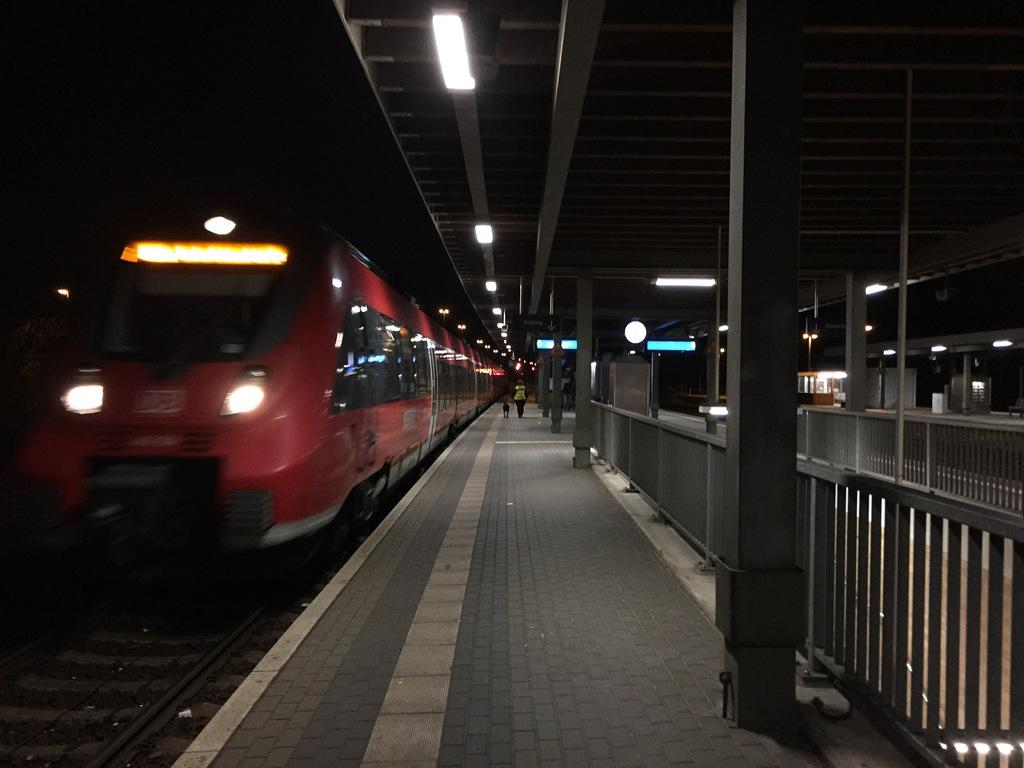What is located on the left side of the image? There is a train on the left side of the image. What is in the middle of the image? There is a platform in the middle of the image. What are the two persons in the background of the image doing? Two persons are walking in the background of the image. What can be seen above the platform in the image? There are lights over the ceiling in the image. What type of wire is being used by the train in the image? There is no wire being used by the train in the image. What is the beef being used for in the image? There is no beef present in the image. 